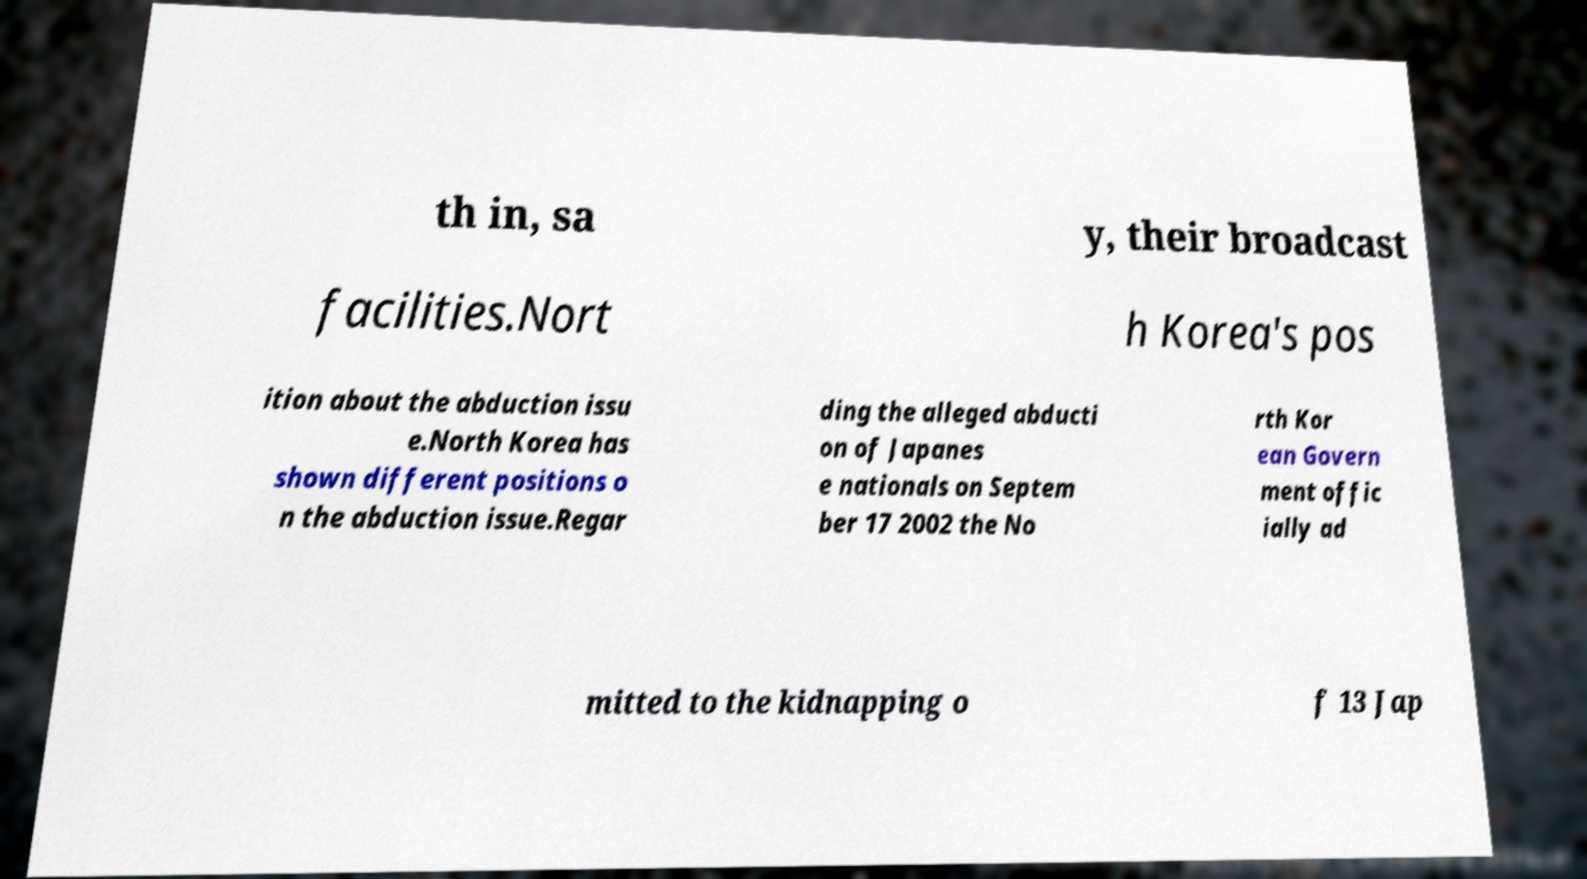What messages or text are displayed in this image? I need them in a readable, typed format. th in, sa y, their broadcast facilities.Nort h Korea's pos ition about the abduction issu e.North Korea has shown different positions o n the abduction issue.Regar ding the alleged abducti on of Japanes e nationals on Septem ber 17 2002 the No rth Kor ean Govern ment offic ially ad mitted to the kidnapping o f 13 Jap 